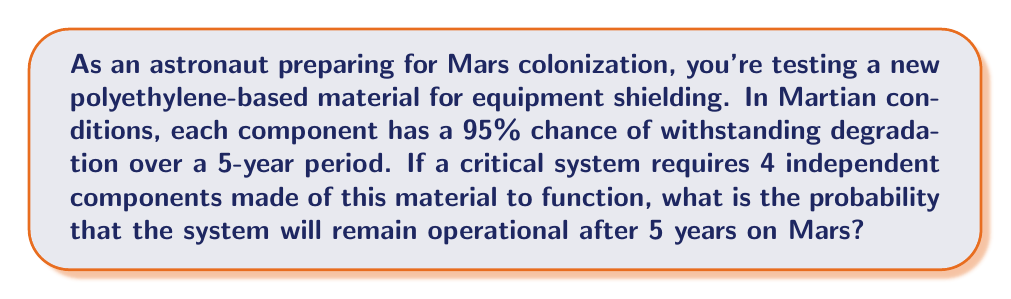Teach me how to tackle this problem. Let's approach this step-by-step:

1) First, we need to understand what the question is asking. We're looking for the probability that ALL 4 components will survive for 5 years.

2) We're given that each component has a 95% chance of surviving. In probability terms, this is 0.95.

3) The components are independent, meaning the survival of one doesn't affect the others. In such cases, we multiply the individual probabilities.

4) The probability of all 4 components surviving is:

   $$P(\text{all survive}) = 0.95 \times 0.95 \times 0.95 \times 0.95 = 0.95^4$$

5) Let's calculate this:

   $$0.95^4 = 0.8145061$$

6) Converting to a percentage:

   $$0.8145061 \times 100\% = 81.45061\%$$

Therefore, there is approximately an 81.45% chance that the system will remain operational after 5 years on Mars.
Answer: $0.8145$ or $81.45\%$ 